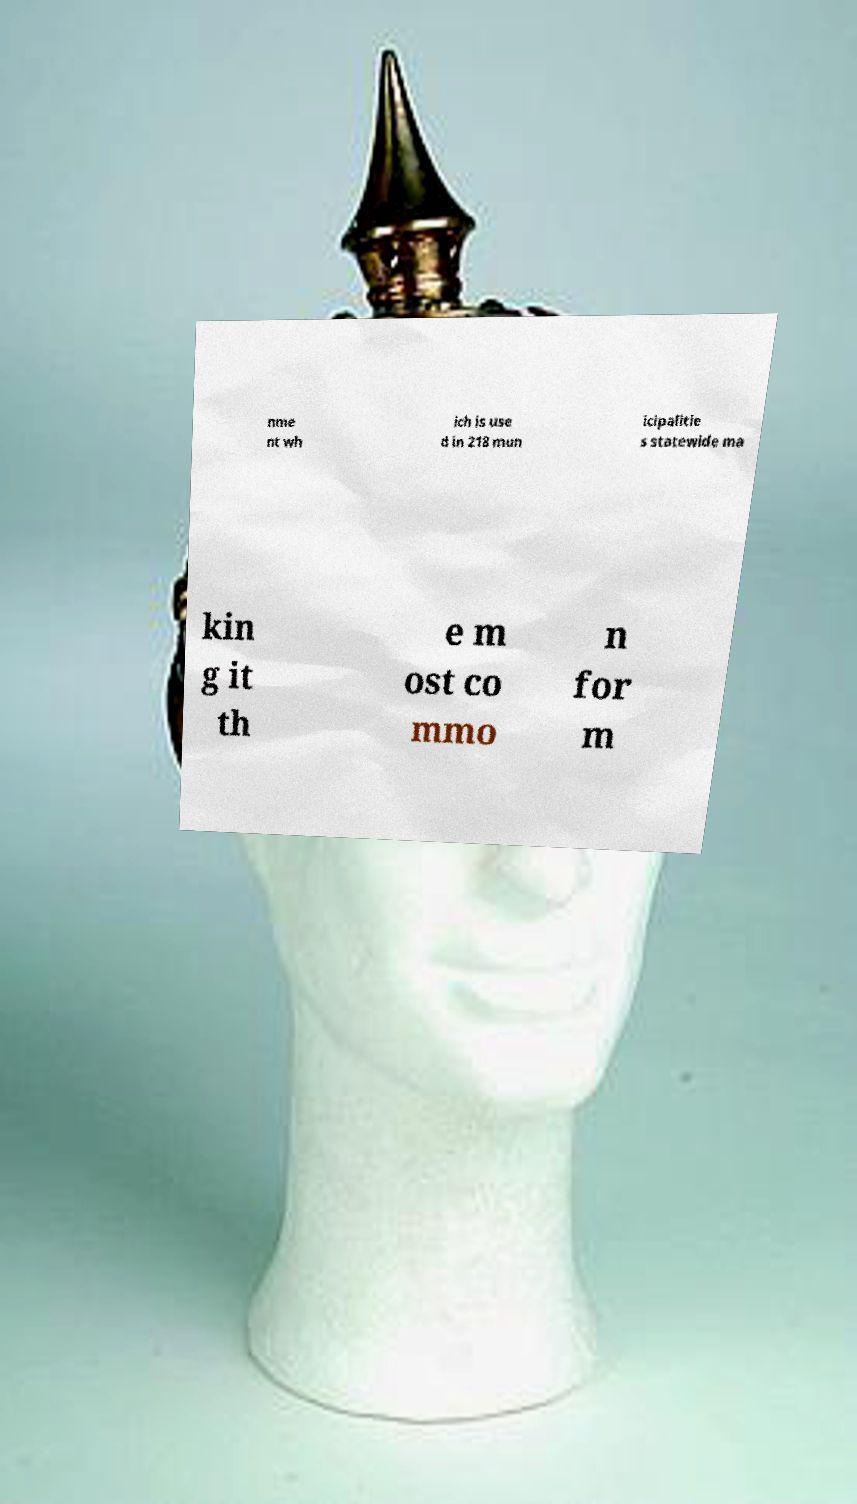For documentation purposes, I need the text within this image transcribed. Could you provide that? nme nt wh ich is use d in 218 mun icipalitie s statewide ma kin g it th e m ost co mmo n for m 